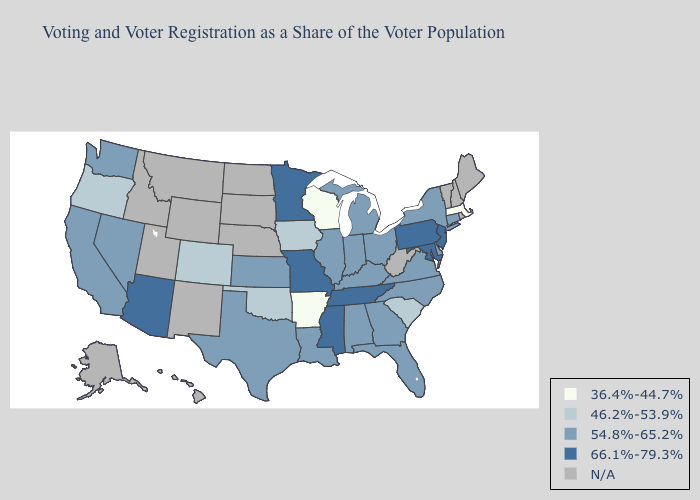Does Massachusetts have the highest value in the Northeast?
Answer briefly. No. Does the first symbol in the legend represent the smallest category?
Be succinct. Yes. Does Alabama have the highest value in the USA?
Keep it brief. No. Among the states that border New Jersey , which have the highest value?
Be succinct. Pennsylvania. Is the legend a continuous bar?
Keep it brief. No. Among the states that border Kentucky , which have the lowest value?
Write a very short answer. Illinois, Indiana, Ohio, Virginia. Does Missouri have the highest value in the MidWest?
Concise answer only. Yes. What is the lowest value in the USA?
Keep it brief. 36.4%-44.7%. Which states have the highest value in the USA?
Concise answer only. Arizona, Maryland, Minnesota, Mississippi, Missouri, New Jersey, Pennsylvania, Tennessee. Among the states that border Tennessee , which have the lowest value?
Concise answer only. Arkansas. What is the value of Colorado?
Be succinct. 46.2%-53.9%. Does New York have the highest value in the Northeast?
Be succinct. No. Does the first symbol in the legend represent the smallest category?
Short answer required. Yes. Name the states that have a value in the range 36.4%-44.7%?
Answer briefly. Arkansas, Massachusetts, Wisconsin. 